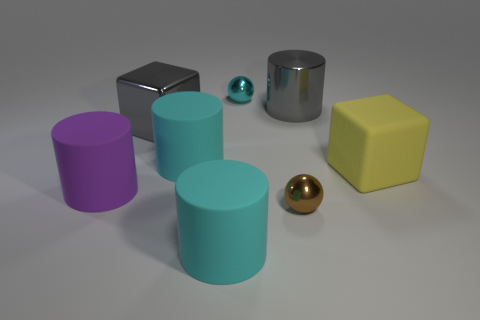Subtract all large matte cylinders. How many cylinders are left? 1 Subtract all cyan spheres. How many spheres are left? 1 Subtract 1 cylinders. How many cylinders are left? 3 Subtract all balls. How many objects are left? 6 Add 1 large matte cylinders. How many objects exist? 9 Subtract all gray cylinders. Subtract all brown cubes. How many cylinders are left? 3 Subtract all gray cylinders. How many purple blocks are left? 0 Subtract all large cyan matte cylinders. Subtract all yellow matte blocks. How many objects are left? 5 Add 1 large purple rubber things. How many large purple rubber things are left? 2 Add 1 cyan matte cylinders. How many cyan matte cylinders exist? 3 